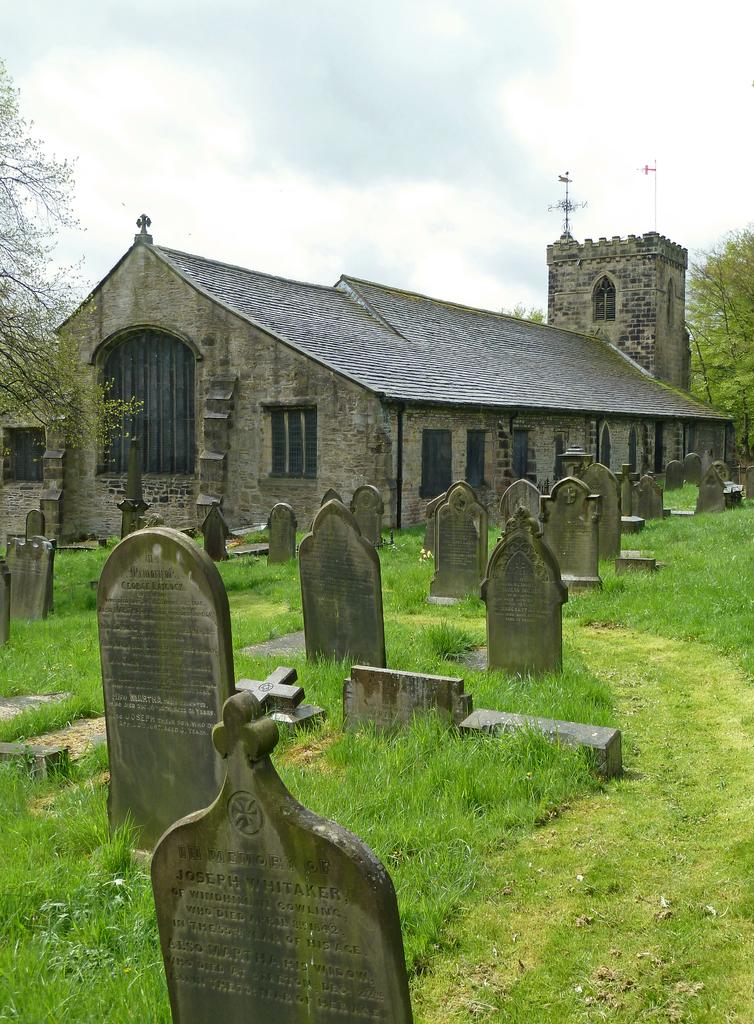What type of vegetation can be seen in the image? There is grass in the image. What type of location is depicted in the image? There is a graveyard in the image. What type of building is present in the image? There is a house in the image. What other natural elements can be seen in the image? There are trees in the image. What is visible at the top of the image? The sky is visible at the top of the image. What is the price of the guitar in the image? There is no guitar present in the image. How many cattle can be seen grazing in the image? There are no cattle present in the image. 